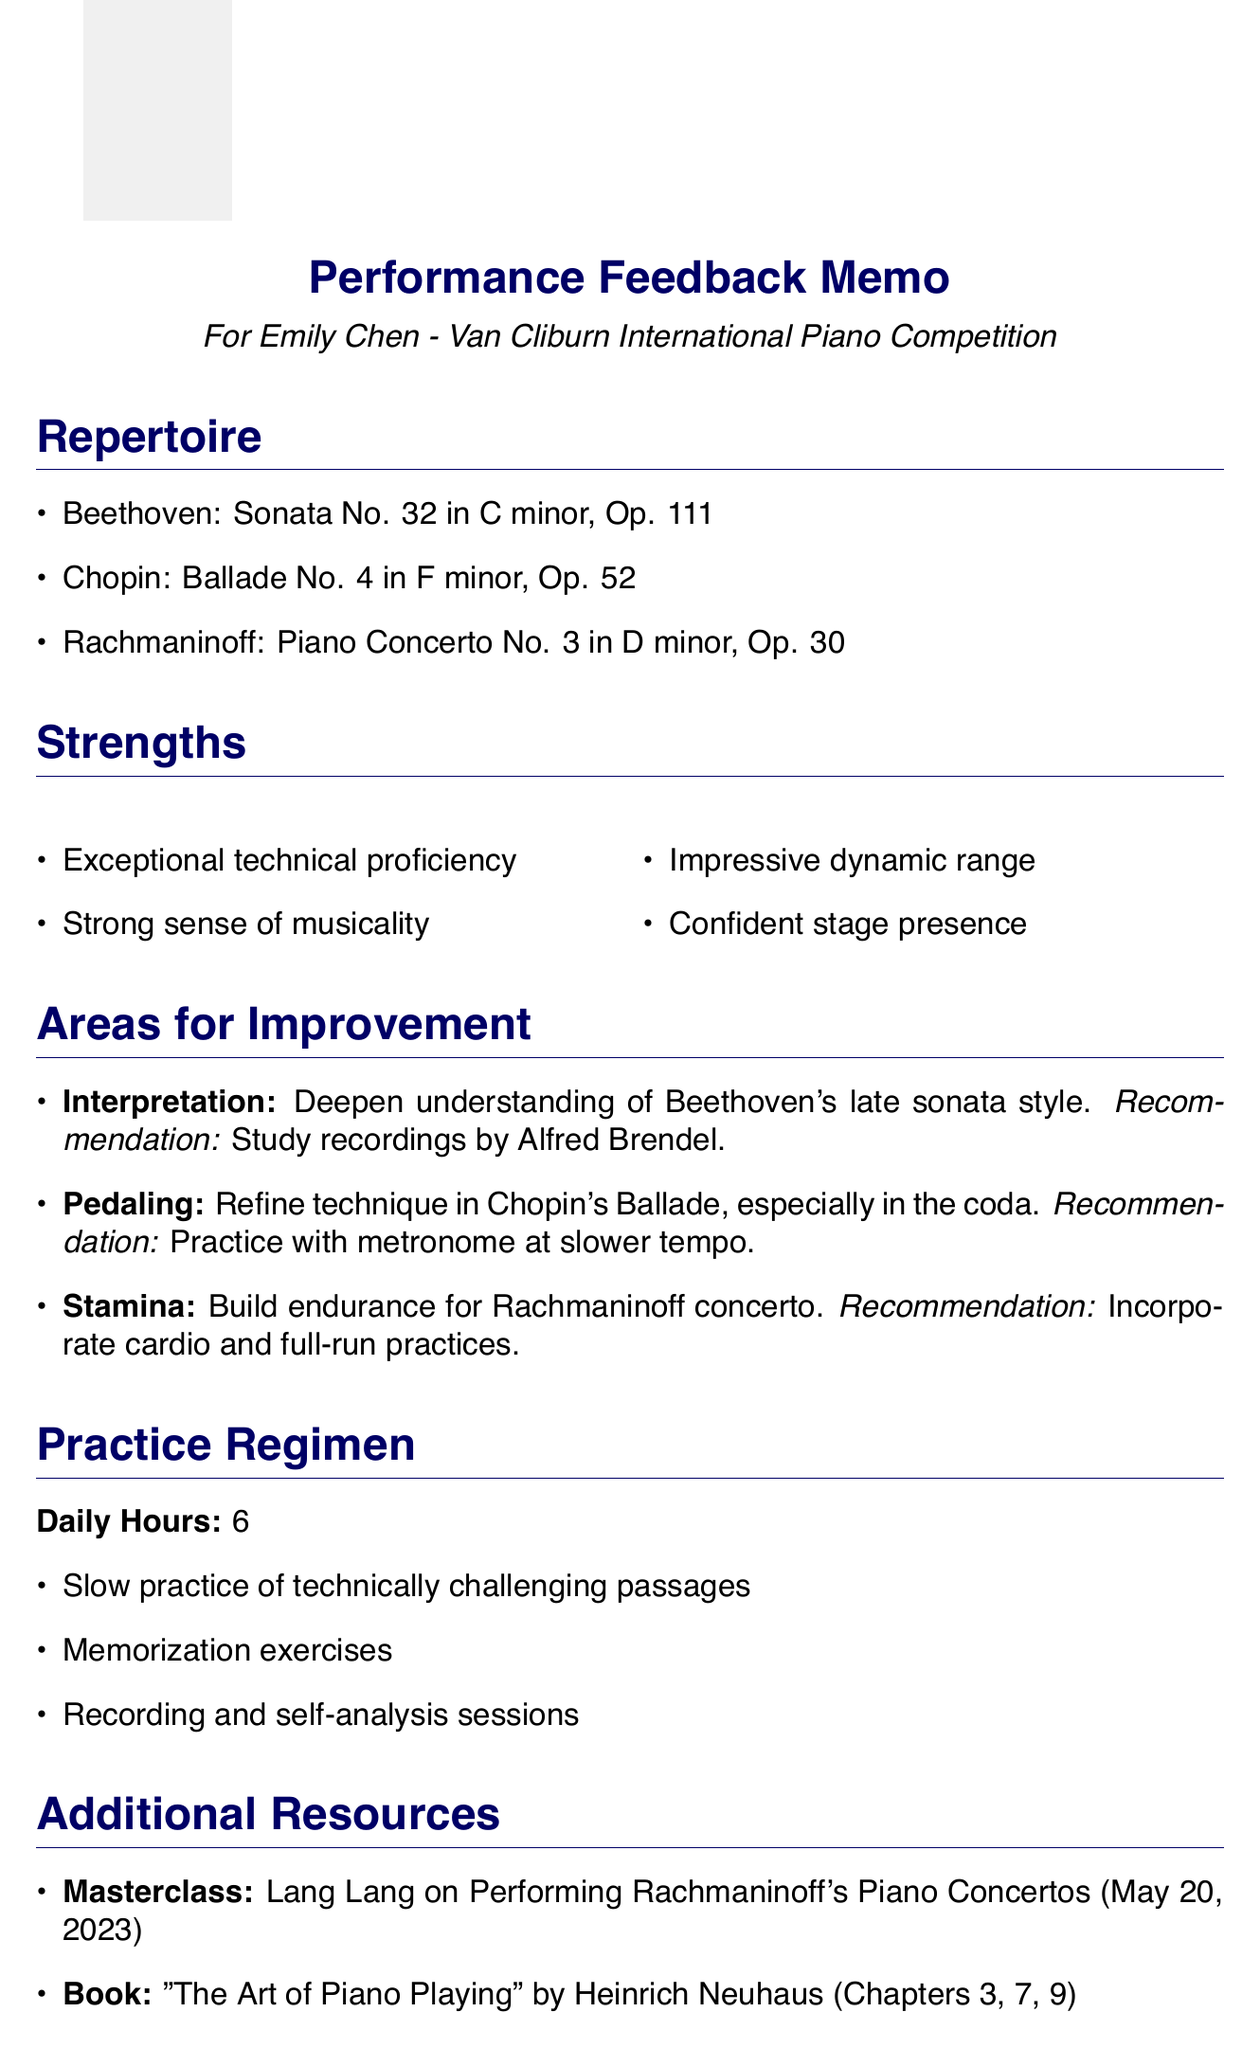What is the student's name? The student's name is presented in the header of the memo.
Answer: Emily Chen What repertoire piece was composed by Beethoven? The document lists the repertoire pieces, including the one by Beethoven.
Answer: Sonata No. 32 in C minor, Op. 111 What is the recommended practice focus for improving stamina? The document mentions a specific recommendation regarding building endurance.
Answer: Incorporate cardio and full-run practices Who is the instructor of the masterclass listed in the additional resources? The document includes details about a masterclass and its instructor.
Answer: Lang Lang What is the date of the student's next evaluation? The next evaluation date is specified at the end of the memo.
Answer: May 30, 2023 What aspect of performance should Emily improve related to interpretation? The document identifies a specific aspect that requires improvement and details about it.
Answer: Deepen understanding of Beethoven's late sonata style Which book is recommended in the additional resources? The document lists additional resources, including the title of a recommended book.
Answer: The Art of Piano Playing What is the total number of daily practice hours recommended? The document specifies how many hours Emily should practice each day.
Answer: 6 What is the main topic of the masterclass? The document states the subject matter of the masterclass offered by Lang Lang.
Answer: Performing Rachmaninoff's Piano Concertos 